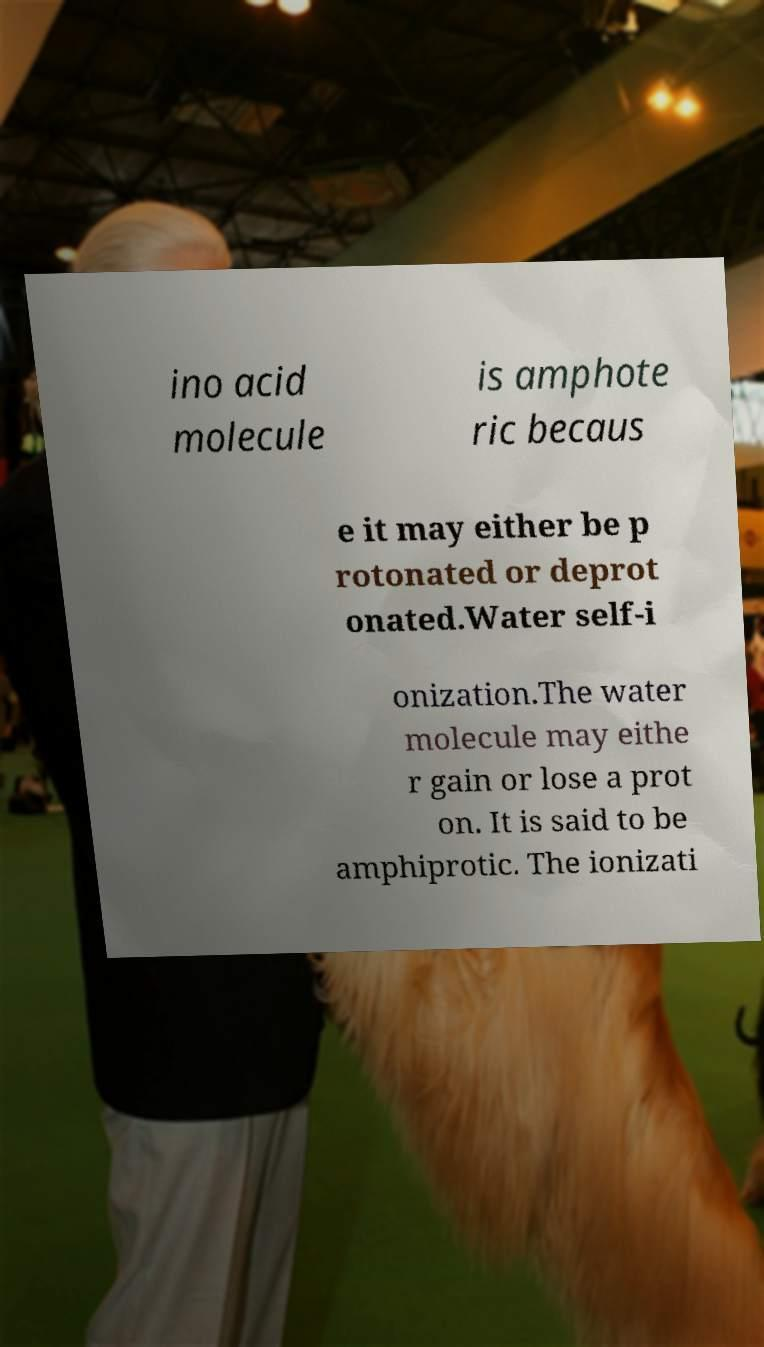For documentation purposes, I need the text within this image transcribed. Could you provide that? ino acid molecule is amphote ric becaus e it may either be p rotonated or deprot onated.Water self-i onization.The water molecule may eithe r gain or lose a prot on. It is said to be amphiprotic. The ionizati 